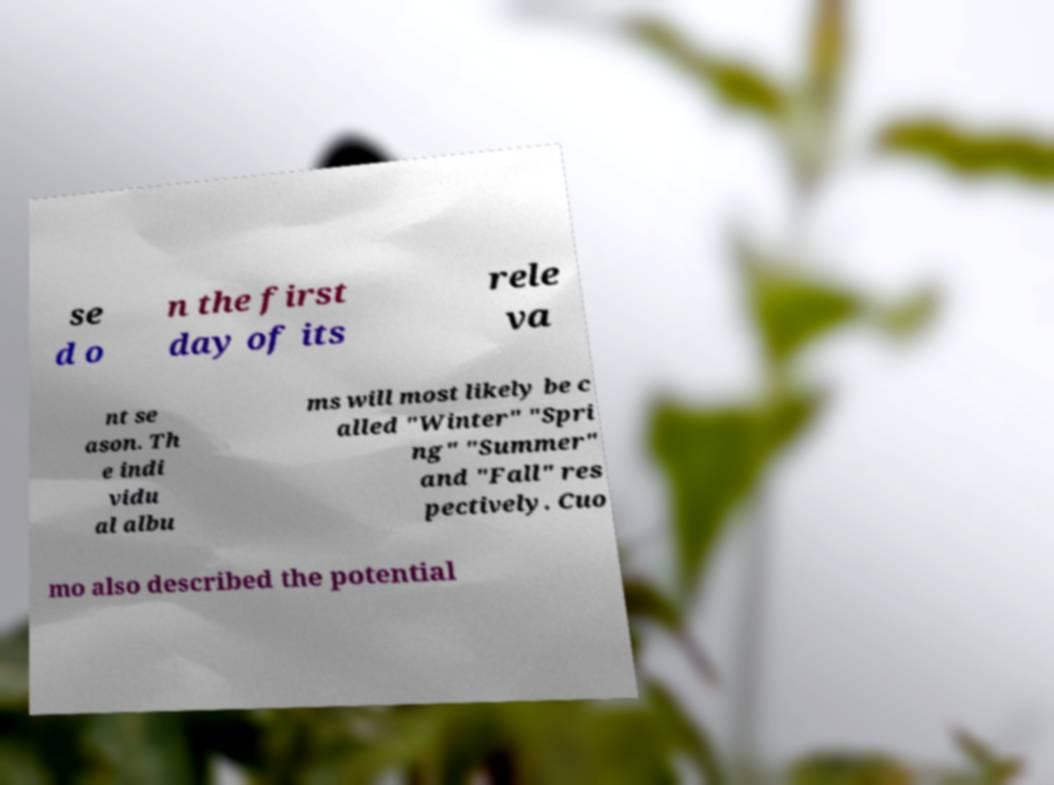Can you read and provide the text displayed in the image?This photo seems to have some interesting text. Can you extract and type it out for me? se d o n the first day of its rele va nt se ason. Th e indi vidu al albu ms will most likely be c alled "Winter" "Spri ng" "Summer" and "Fall" res pectively. Cuo mo also described the potential 